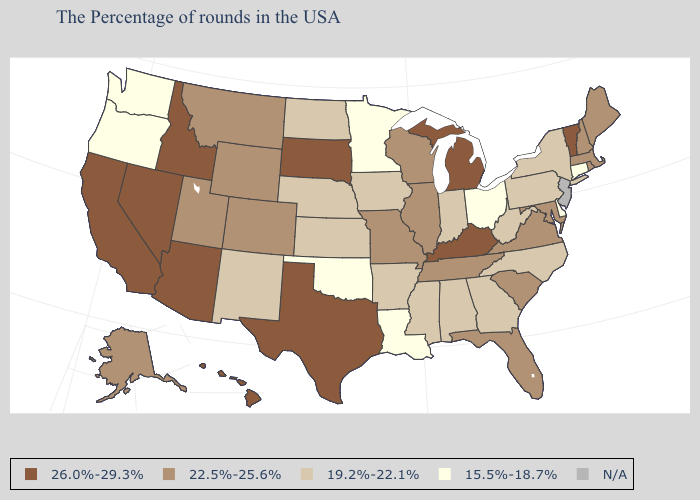Which states have the lowest value in the USA?
Answer briefly. Connecticut, Delaware, Ohio, Louisiana, Minnesota, Oklahoma, Washington, Oregon. Name the states that have a value in the range 22.5%-25.6%?
Give a very brief answer. Maine, Massachusetts, Rhode Island, New Hampshire, Maryland, Virginia, South Carolina, Florida, Tennessee, Wisconsin, Illinois, Missouri, Wyoming, Colorado, Utah, Montana, Alaska. Which states have the lowest value in the USA?
Concise answer only. Connecticut, Delaware, Ohio, Louisiana, Minnesota, Oklahoma, Washington, Oregon. What is the value of Mississippi?
Give a very brief answer. 19.2%-22.1%. What is the lowest value in states that border North Dakota?
Answer briefly. 15.5%-18.7%. Name the states that have a value in the range 26.0%-29.3%?
Be succinct. Vermont, Michigan, Kentucky, Texas, South Dakota, Arizona, Idaho, Nevada, California, Hawaii. Does Vermont have the lowest value in the Northeast?
Keep it brief. No. What is the value of Illinois?
Write a very short answer. 22.5%-25.6%. What is the lowest value in the South?
Concise answer only. 15.5%-18.7%. Which states have the lowest value in the USA?
Quick response, please. Connecticut, Delaware, Ohio, Louisiana, Minnesota, Oklahoma, Washington, Oregon. What is the lowest value in the Northeast?
Short answer required. 15.5%-18.7%. Which states have the highest value in the USA?
Quick response, please. Vermont, Michigan, Kentucky, Texas, South Dakota, Arizona, Idaho, Nevada, California, Hawaii. Among the states that border Montana , which have the highest value?
Write a very short answer. South Dakota, Idaho. Name the states that have a value in the range 19.2%-22.1%?
Keep it brief. New York, Pennsylvania, North Carolina, West Virginia, Georgia, Indiana, Alabama, Mississippi, Arkansas, Iowa, Kansas, Nebraska, North Dakota, New Mexico. Which states hav the highest value in the South?
Short answer required. Kentucky, Texas. 